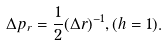<formula> <loc_0><loc_0><loc_500><loc_500>\Delta p _ { r } = \frac { 1 } { 2 } ( \Delta r ) ^ { - 1 } , ( h = 1 ) .</formula> 